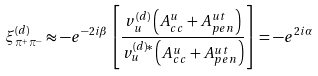<formula> <loc_0><loc_0><loc_500><loc_500>\xi ^ { ( d ) } _ { \pi ^ { + } \pi ^ { - } } \approx - e ^ { - 2 i \beta } \left [ \frac { v _ { u } ^ { ( d ) } \left ( A _ { c c } ^ { u } + A ^ { u t } _ { p e n } \right ) } { v _ { u } ^ { ( d ) \ast } \left ( A _ { c c } ^ { u } + A ^ { u t } _ { p e n } \right ) } \right ] = - e ^ { 2 i \alpha }</formula> 